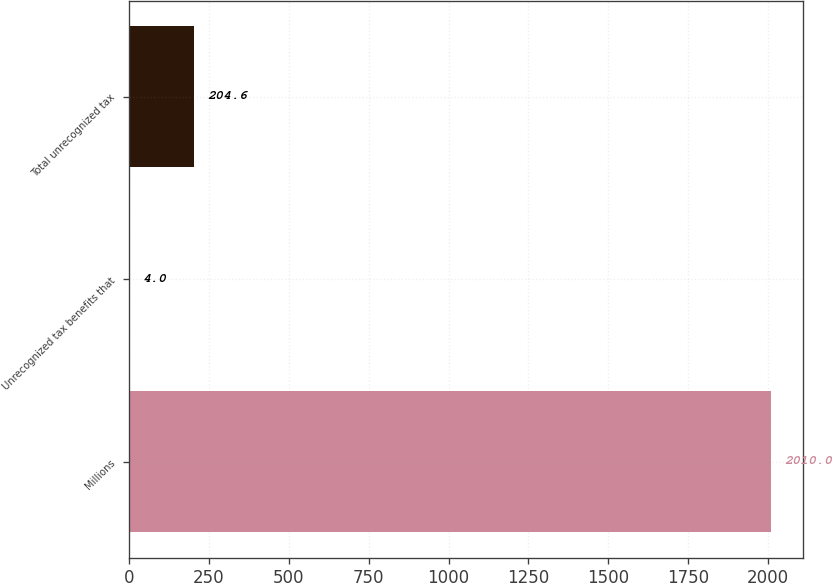Convert chart. <chart><loc_0><loc_0><loc_500><loc_500><bar_chart><fcel>Millions<fcel>Unrecognized tax benefits that<fcel>Total unrecognized tax<nl><fcel>2010<fcel>4<fcel>204.6<nl></chart> 